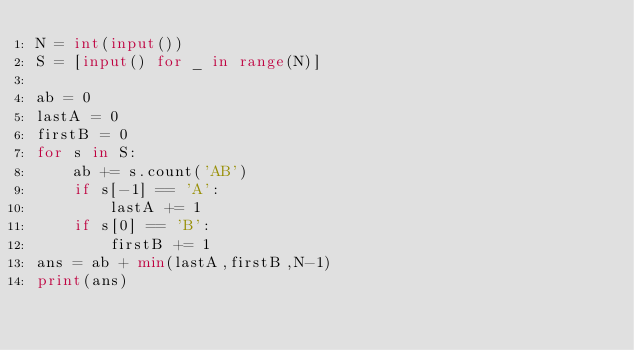Convert code to text. <code><loc_0><loc_0><loc_500><loc_500><_Python_>N = int(input())
S = [input() for _ in range(N)]

ab = 0
lastA = 0
firstB = 0
for s in S:
    ab += s.count('AB')
    if s[-1] == 'A':
        lastA += 1
    if s[0] == 'B':
        firstB += 1
ans = ab + min(lastA,firstB,N-1)
print(ans)</code> 